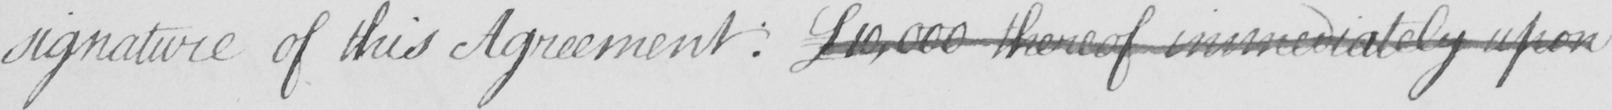Can you tell me what this handwritten text says? signature of this Agreement ; £10,000 thereof immediately upon 